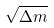<formula> <loc_0><loc_0><loc_500><loc_500>\sqrt { \Delta m }</formula> 